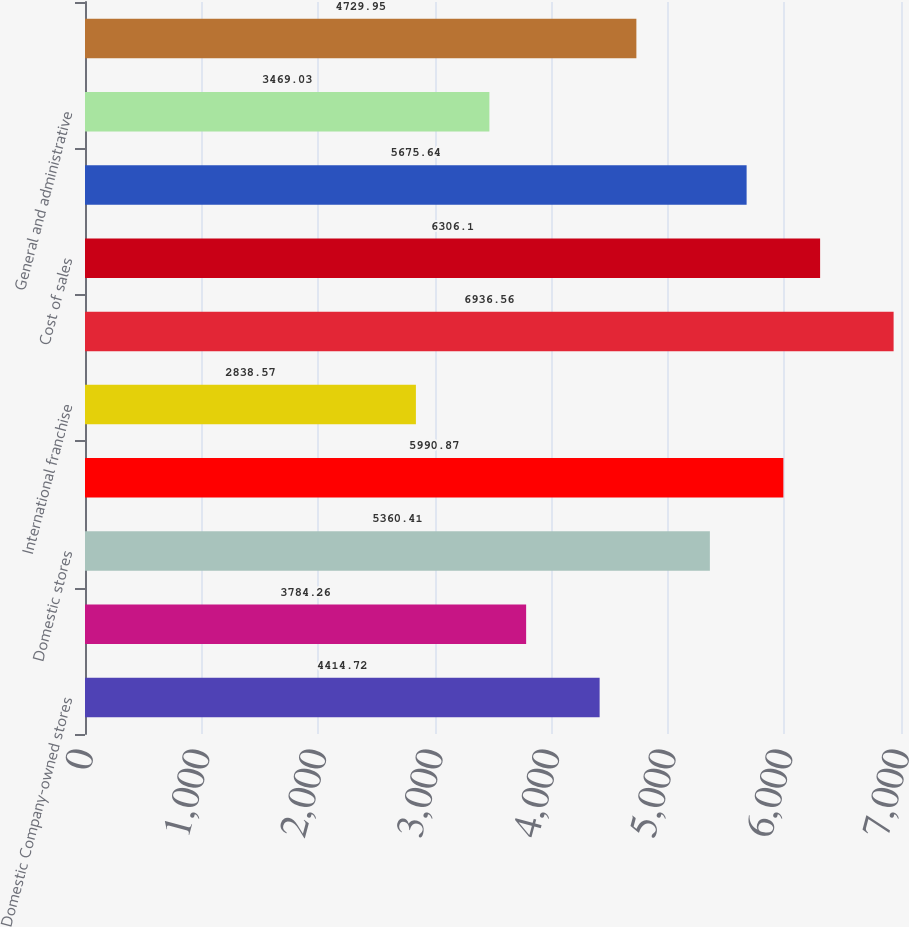<chart> <loc_0><loc_0><loc_500><loc_500><bar_chart><fcel>Domestic Company-owned stores<fcel>Domestic franchise<fcel>Domestic stores<fcel>Supply chain<fcel>International franchise<fcel>Total revenues<fcel>Cost of sales<fcel>Operating margin<fcel>General and administrative<fcel>Income from operations<nl><fcel>4414.72<fcel>3784.26<fcel>5360.41<fcel>5990.87<fcel>2838.57<fcel>6936.56<fcel>6306.1<fcel>5675.64<fcel>3469.03<fcel>4729.95<nl></chart> 